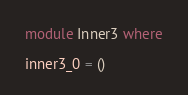Convert code to text. <code><loc_0><loc_0><loc_500><loc_500><_Haskell_>module Inner3 where

inner3_0 = ()
</code> 